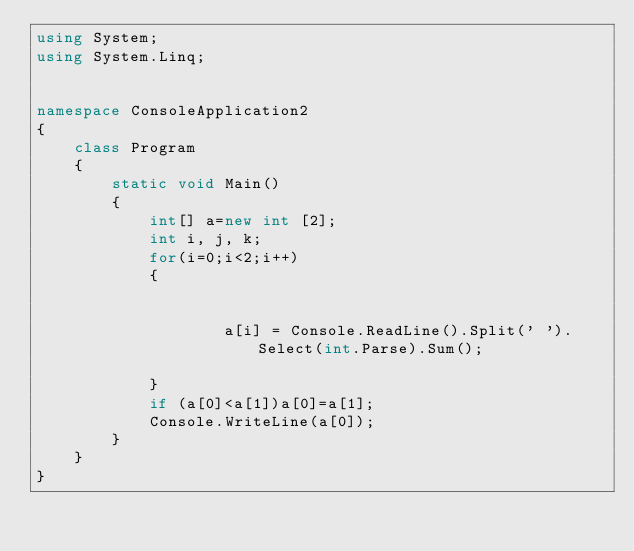Convert code to text. <code><loc_0><loc_0><loc_500><loc_500><_C#_>using System;
using System.Linq;


namespace ConsoleApplication2
{
    class Program
    {
        static void Main()
        {
            int[] a=new int [2];
            int i, j, k;
            for(i=0;i<2;i++)
            {

                
                    a[i] = Console.ReadLine().Split(' ').Select(int.Parse).Sum();
                
            }
            if (a[0]<a[1])a[0]=a[1];
            Console.WriteLine(a[0]);
        }
    }
}</code> 